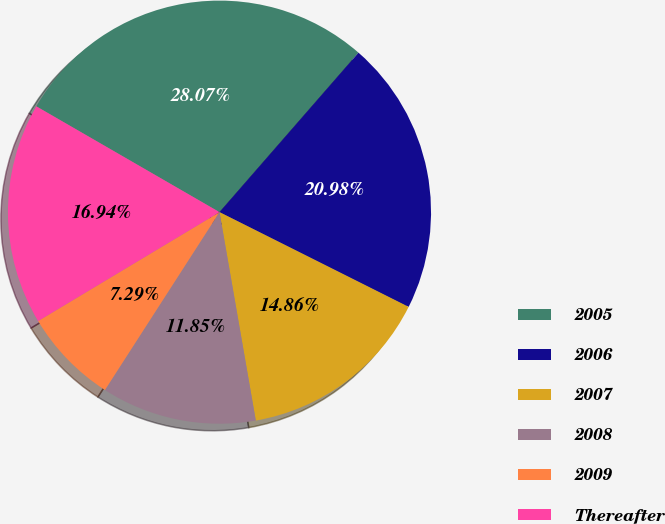<chart> <loc_0><loc_0><loc_500><loc_500><pie_chart><fcel>2005<fcel>2006<fcel>2007<fcel>2008<fcel>2009<fcel>Thereafter<nl><fcel>28.07%<fcel>20.98%<fcel>14.86%<fcel>11.85%<fcel>7.29%<fcel>16.94%<nl></chart> 